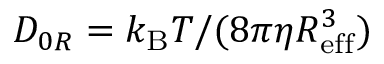Convert formula to latex. <formula><loc_0><loc_0><loc_500><loc_500>D _ { 0 R } = k _ { B } T / ( 8 \pi \eta R _ { e f f } ^ { 3 } )</formula> 